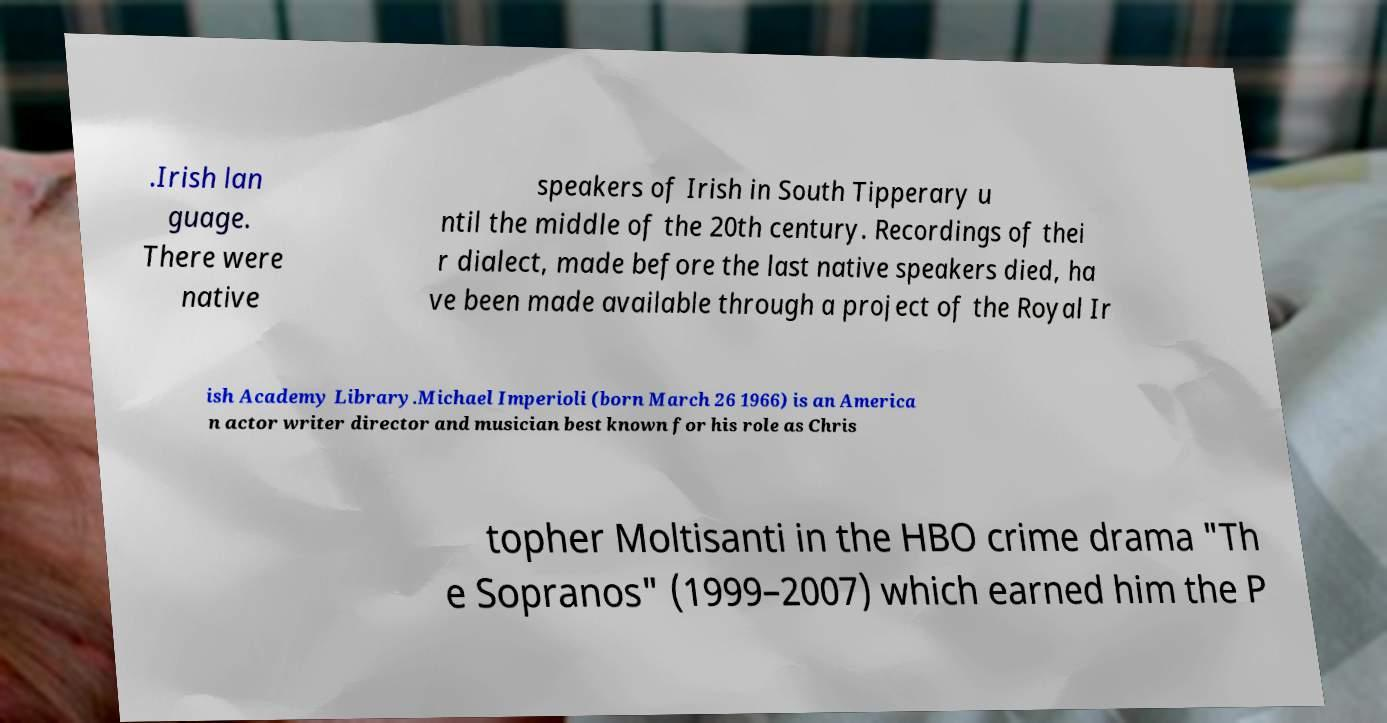Please identify and transcribe the text found in this image. .Irish lan guage. There were native speakers of Irish in South Tipperary u ntil the middle of the 20th century. Recordings of thei r dialect, made before the last native speakers died, ha ve been made available through a project of the Royal Ir ish Academy Library.Michael Imperioli (born March 26 1966) is an America n actor writer director and musician best known for his role as Chris topher Moltisanti in the HBO crime drama "Th e Sopranos" (1999–2007) which earned him the P 